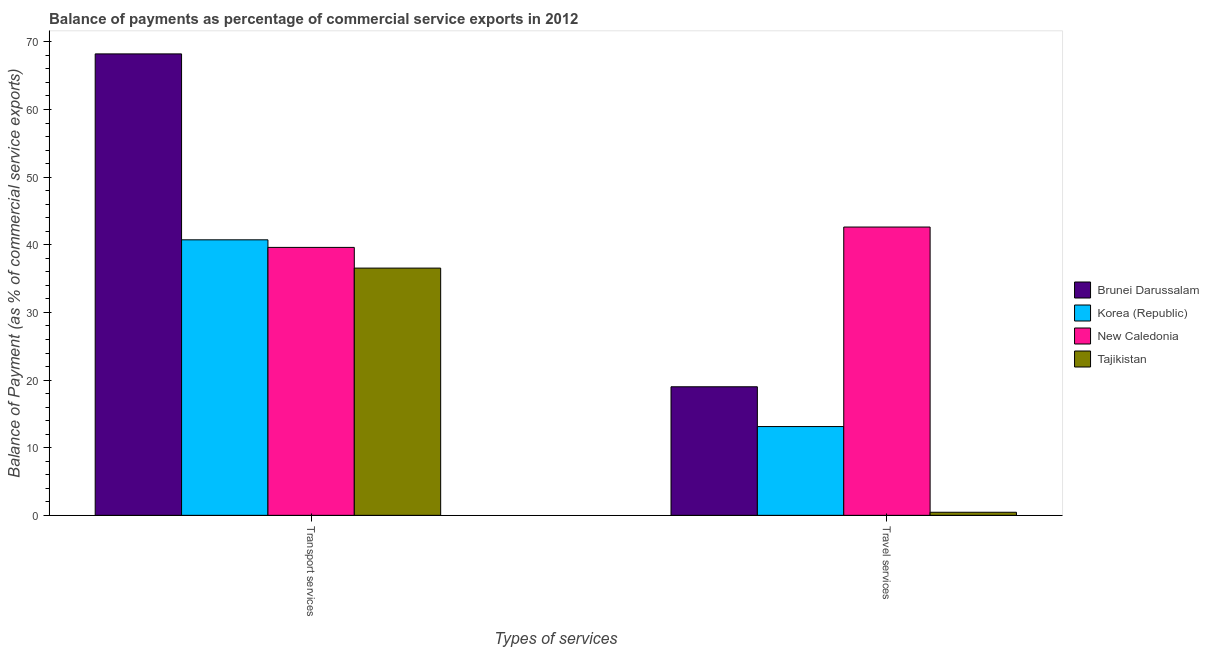How many groups of bars are there?
Give a very brief answer. 2. Are the number of bars on each tick of the X-axis equal?
Make the answer very short. Yes. How many bars are there on the 1st tick from the right?
Your answer should be very brief. 4. What is the label of the 2nd group of bars from the left?
Ensure brevity in your answer.  Travel services. What is the balance of payments of transport services in Tajikistan?
Ensure brevity in your answer.  36.55. Across all countries, what is the maximum balance of payments of travel services?
Give a very brief answer. 42.62. Across all countries, what is the minimum balance of payments of transport services?
Give a very brief answer. 36.55. In which country was the balance of payments of transport services maximum?
Your response must be concise. Brunei Darussalam. In which country was the balance of payments of travel services minimum?
Make the answer very short. Tajikistan. What is the total balance of payments of travel services in the graph?
Ensure brevity in your answer.  75.21. What is the difference between the balance of payments of transport services in Korea (Republic) and that in Brunei Darussalam?
Your answer should be very brief. -27.49. What is the difference between the balance of payments of transport services in Brunei Darussalam and the balance of payments of travel services in Korea (Republic)?
Your answer should be very brief. 55.1. What is the average balance of payments of travel services per country?
Keep it short and to the point. 18.8. What is the difference between the balance of payments of travel services and balance of payments of transport services in Brunei Darussalam?
Provide a short and direct response. -49.21. What is the ratio of the balance of payments of transport services in Korea (Republic) to that in Brunei Darussalam?
Your answer should be compact. 0.6. In how many countries, is the balance of payments of transport services greater than the average balance of payments of transport services taken over all countries?
Offer a terse response. 1. What does the 4th bar from the left in Travel services represents?
Your response must be concise. Tajikistan. What does the 4th bar from the right in Travel services represents?
Ensure brevity in your answer.  Brunei Darussalam. How many bars are there?
Make the answer very short. 8. How many countries are there in the graph?
Ensure brevity in your answer.  4. Are the values on the major ticks of Y-axis written in scientific E-notation?
Provide a short and direct response. No. Does the graph contain any zero values?
Offer a very short reply. No. Where does the legend appear in the graph?
Your answer should be very brief. Center right. What is the title of the graph?
Offer a terse response. Balance of payments as percentage of commercial service exports in 2012. Does "Mali" appear as one of the legend labels in the graph?
Provide a short and direct response. No. What is the label or title of the X-axis?
Provide a succinct answer. Types of services. What is the label or title of the Y-axis?
Make the answer very short. Balance of Payment (as % of commercial service exports). What is the Balance of Payment (as % of commercial service exports) in Brunei Darussalam in Transport services?
Your answer should be compact. 68.22. What is the Balance of Payment (as % of commercial service exports) of Korea (Republic) in Transport services?
Offer a terse response. 40.73. What is the Balance of Payment (as % of commercial service exports) of New Caledonia in Transport services?
Provide a succinct answer. 39.61. What is the Balance of Payment (as % of commercial service exports) of Tajikistan in Transport services?
Provide a succinct answer. 36.55. What is the Balance of Payment (as % of commercial service exports) of Brunei Darussalam in Travel services?
Provide a short and direct response. 19.01. What is the Balance of Payment (as % of commercial service exports) in Korea (Republic) in Travel services?
Keep it short and to the point. 13.13. What is the Balance of Payment (as % of commercial service exports) of New Caledonia in Travel services?
Offer a very short reply. 42.62. What is the Balance of Payment (as % of commercial service exports) in Tajikistan in Travel services?
Ensure brevity in your answer.  0.46. Across all Types of services, what is the maximum Balance of Payment (as % of commercial service exports) of Brunei Darussalam?
Offer a very short reply. 68.22. Across all Types of services, what is the maximum Balance of Payment (as % of commercial service exports) in Korea (Republic)?
Your answer should be very brief. 40.73. Across all Types of services, what is the maximum Balance of Payment (as % of commercial service exports) of New Caledonia?
Offer a terse response. 42.62. Across all Types of services, what is the maximum Balance of Payment (as % of commercial service exports) in Tajikistan?
Offer a very short reply. 36.55. Across all Types of services, what is the minimum Balance of Payment (as % of commercial service exports) of Brunei Darussalam?
Make the answer very short. 19.01. Across all Types of services, what is the minimum Balance of Payment (as % of commercial service exports) of Korea (Republic)?
Make the answer very short. 13.13. Across all Types of services, what is the minimum Balance of Payment (as % of commercial service exports) in New Caledonia?
Your response must be concise. 39.61. Across all Types of services, what is the minimum Balance of Payment (as % of commercial service exports) of Tajikistan?
Give a very brief answer. 0.46. What is the total Balance of Payment (as % of commercial service exports) of Brunei Darussalam in the graph?
Provide a succinct answer. 87.23. What is the total Balance of Payment (as % of commercial service exports) of Korea (Republic) in the graph?
Your answer should be compact. 53.86. What is the total Balance of Payment (as % of commercial service exports) in New Caledonia in the graph?
Keep it short and to the point. 82.24. What is the total Balance of Payment (as % of commercial service exports) in Tajikistan in the graph?
Provide a succinct answer. 37.01. What is the difference between the Balance of Payment (as % of commercial service exports) of Brunei Darussalam in Transport services and that in Travel services?
Offer a terse response. 49.21. What is the difference between the Balance of Payment (as % of commercial service exports) of Korea (Republic) in Transport services and that in Travel services?
Provide a short and direct response. 27.61. What is the difference between the Balance of Payment (as % of commercial service exports) in New Caledonia in Transport services and that in Travel services?
Your response must be concise. -3.01. What is the difference between the Balance of Payment (as % of commercial service exports) in Tajikistan in Transport services and that in Travel services?
Give a very brief answer. 36.1. What is the difference between the Balance of Payment (as % of commercial service exports) of Brunei Darussalam in Transport services and the Balance of Payment (as % of commercial service exports) of Korea (Republic) in Travel services?
Make the answer very short. 55.1. What is the difference between the Balance of Payment (as % of commercial service exports) of Brunei Darussalam in Transport services and the Balance of Payment (as % of commercial service exports) of New Caledonia in Travel services?
Give a very brief answer. 25.6. What is the difference between the Balance of Payment (as % of commercial service exports) of Brunei Darussalam in Transport services and the Balance of Payment (as % of commercial service exports) of Tajikistan in Travel services?
Your response must be concise. 67.77. What is the difference between the Balance of Payment (as % of commercial service exports) of Korea (Republic) in Transport services and the Balance of Payment (as % of commercial service exports) of New Caledonia in Travel services?
Make the answer very short. -1.89. What is the difference between the Balance of Payment (as % of commercial service exports) in Korea (Republic) in Transport services and the Balance of Payment (as % of commercial service exports) in Tajikistan in Travel services?
Keep it short and to the point. 40.28. What is the difference between the Balance of Payment (as % of commercial service exports) of New Caledonia in Transport services and the Balance of Payment (as % of commercial service exports) of Tajikistan in Travel services?
Your answer should be very brief. 39.16. What is the average Balance of Payment (as % of commercial service exports) of Brunei Darussalam per Types of services?
Give a very brief answer. 43.61. What is the average Balance of Payment (as % of commercial service exports) of Korea (Republic) per Types of services?
Keep it short and to the point. 26.93. What is the average Balance of Payment (as % of commercial service exports) in New Caledonia per Types of services?
Ensure brevity in your answer.  41.12. What is the average Balance of Payment (as % of commercial service exports) of Tajikistan per Types of services?
Your answer should be very brief. 18.5. What is the difference between the Balance of Payment (as % of commercial service exports) of Brunei Darussalam and Balance of Payment (as % of commercial service exports) of Korea (Republic) in Transport services?
Provide a short and direct response. 27.49. What is the difference between the Balance of Payment (as % of commercial service exports) of Brunei Darussalam and Balance of Payment (as % of commercial service exports) of New Caledonia in Transport services?
Keep it short and to the point. 28.61. What is the difference between the Balance of Payment (as % of commercial service exports) of Brunei Darussalam and Balance of Payment (as % of commercial service exports) of Tajikistan in Transport services?
Offer a terse response. 31.67. What is the difference between the Balance of Payment (as % of commercial service exports) in Korea (Republic) and Balance of Payment (as % of commercial service exports) in New Caledonia in Transport services?
Your answer should be compact. 1.12. What is the difference between the Balance of Payment (as % of commercial service exports) in Korea (Republic) and Balance of Payment (as % of commercial service exports) in Tajikistan in Transport services?
Provide a short and direct response. 4.18. What is the difference between the Balance of Payment (as % of commercial service exports) of New Caledonia and Balance of Payment (as % of commercial service exports) of Tajikistan in Transport services?
Provide a short and direct response. 3.06. What is the difference between the Balance of Payment (as % of commercial service exports) in Brunei Darussalam and Balance of Payment (as % of commercial service exports) in Korea (Republic) in Travel services?
Your response must be concise. 5.88. What is the difference between the Balance of Payment (as % of commercial service exports) of Brunei Darussalam and Balance of Payment (as % of commercial service exports) of New Caledonia in Travel services?
Make the answer very short. -23.62. What is the difference between the Balance of Payment (as % of commercial service exports) in Brunei Darussalam and Balance of Payment (as % of commercial service exports) in Tajikistan in Travel services?
Keep it short and to the point. 18.55. What is the difference between the Balance of Payment (as % of commercial service exports) of Korea (Republic) and Balance of Payment (as % of commercial service exports) of New Caledonia in Travel services?
Ensure brevity in your answer.  -29.5. What is the difference between the Balance of Payment (as % of commercial service exports) of Korea (Republic) and Balance of Payment (as % of commercial service exports) of Tajikistan in Travel services?
Provide a succinct answer. 12.67. What is the difference between the Balance of Payment (as % of commercial service exports) of New Caledonia and Balance of Payment (as % of commercial service exports) of Tajikistan in Travel services?
Offer a terse response. 42.17. What is the ratio of the Balance of Payment (as % of commercial service exports) of Brunei Darussalam in Transport services to that in Travel services?
Provide a short and direct response. 3.59. What is the ratio of the Balance of Payment (as % of commercial service exports) of Korea (Republic) in Transport services to that in Travel services?
Your answer should be compact. 3.1. What is the ratio of the Balance of Payment (as % of commercial service exports) in New Caledonia in Transport services to that in Travel services?
Your answer should be very brief. 0.93. What is the ratio of the Balance of Payment (as % of commercial service exports) of Tajikistan in Transport services to that in Travel services?
Provide a succinct answer. 80. What is the difference between the highest and the second highest Balance of Payment (as % of commercial service exports) in Brunei Darussalam?
Your answer should be compact. 49.21. What is the difference between the highest and the second highest Balance of Payment (as % of commercial service exports) in Korea (Republic)?
Provide a succinct answer. 27.61. What is the difference between the highest and the second highest Balance of Payment (as % of commercial service exports) of New Caledonia?
Make the answer very short. 3.01. What is the difference between the highest and the second highest Balance of Payment (as % of commercial service exports) of Tajikistan?
Your response must be concise. 36.1. What is the difference between the highest and the lowest Balance of Payment (as % of commercial service exports) of Brunei Darussalam?
Your response must be concise. 49.21. What is the difference between the highest and the lowest Balance of Payment (as % of commercial service exports) of Korea (Republic)?
Your answer should be very brief. 27.61. What is the difference between the highest and the lowest Balance of Payment (as % of commercial service exports) in New Caledonia?
Offer a very short reply. 3.01. What is the difference between the highest and the lowest Balance of Payment (as % of commercial service exports) of Tajikistan?
Provide a succinct answer. 36.1. 